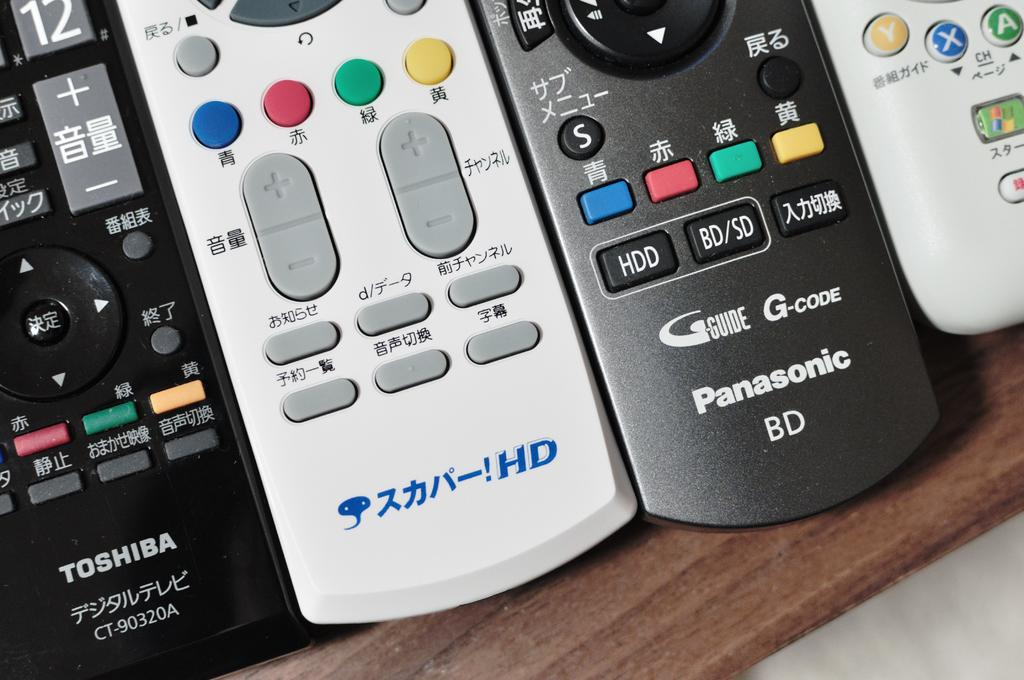<image>
Provide a brief description of the given image. several tv remotes, such as toshiba and panasonic 